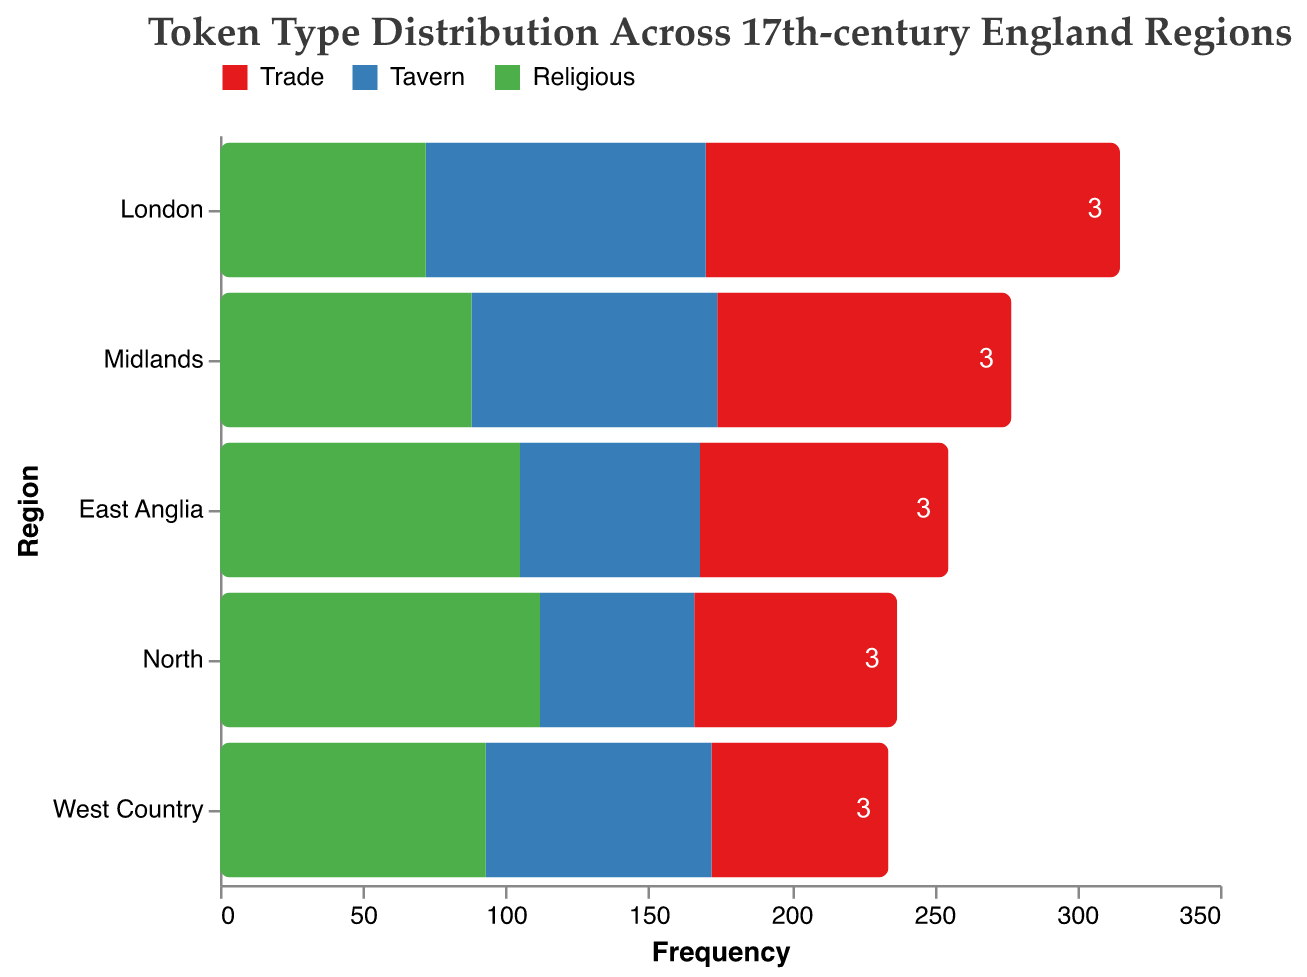How is the title of the figure phrased? The title is located at the top of the figure. It reads "Token Type Distribution Across 17th-century England Regions"
Answer: Token Type Distribution Across 17th-century England Regions Which token type has the highest frequency in London? In the mosaic plot, observe the bar sections corresponding to London under each token type color. The "Trade" token has the longest bar
Answer: Trade What is the combined frequency of all token types in the West Country? Sum the frequencies of each token type in the West Country: Trade (62) + Tavern (79) + Religious (93) = 234
Answer: 234 How does the frequency of "Tavern" tokens in the Midlands compare to the North? Compare the lengths of the sections for "Tavern" tokens in the Midlands and the North. Midlands has 86, and North has 54, hence Midlands has a greater frequency
Answer: Midlands has more What is the total number of regions depicted in the figure? Count the distinct regions listed along the y-axis in the mosaic plot. Regions include London, East Anglia, West Country, Midlands, and North
Answer: 5 Which region has the highest frequency of religious tokens? Look at the bar sections for religious tokens and find the longest one associated with a region. The North's section is the longest with a frequency of 112
Answer: North Is the frequency of trade tokens in East Anglia greater than in the Midlands? Compare the bar lengths for "Trade" tokens in East Anglia (87) and the Midlands (103). Midlands' frequency is higher
Answer: No Which token type generally has the lowest frequency across all regions? Observe the average lengths of bar sections for each token type across all regions. Tavern tokens are generally shorter compared to Trade and Religious tokens
Answer: Tavern What is the difference in frequency of religious tokens between East Anglia and London? Subtract the frequency of religious tokens in London (72) from that in East Anglia (105). 105 - 72 = 33
Answer: 33 Which region has the most balanced distribution of token types? Look for regions where the bar sections of "Trade," "Tavern," and "Religious" tokens are relatively similar in length. The Midlands has bars of frequencies 103 (Trade), 86 (Tavern), and 88 (Religious), showing similarity
Answer: Midlands 